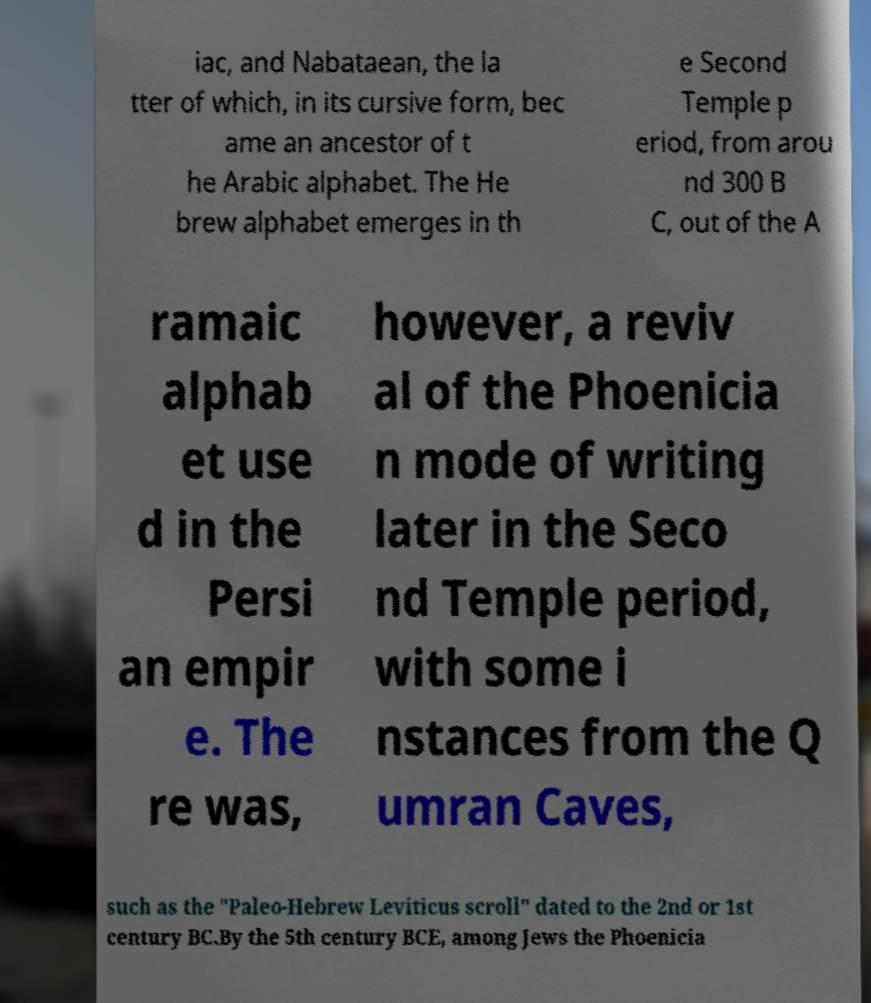What messages or text are displayed in this image? I need them in a readable, typed format. iac, and Nabataean, the la tter of which, in its cursive form, bec ame an ancestor of t he Arabic alphabet. The He brew alphabet emerges in th e Second Temple p eriod, from arou nd 300 B C, out of the A ramaic alphab et use d in the Persi an empir e. The re was, however, a reviv al of the Phoenicia n mode of writing later in the Seco nd Temple period, with some i nstances from the Q umran Caves, such as the "Paleo-Hebrew Leviticus scroll" dated to the 2nd or 1st century BC.By the 5th century BCE, among Jews the Phoenicia 